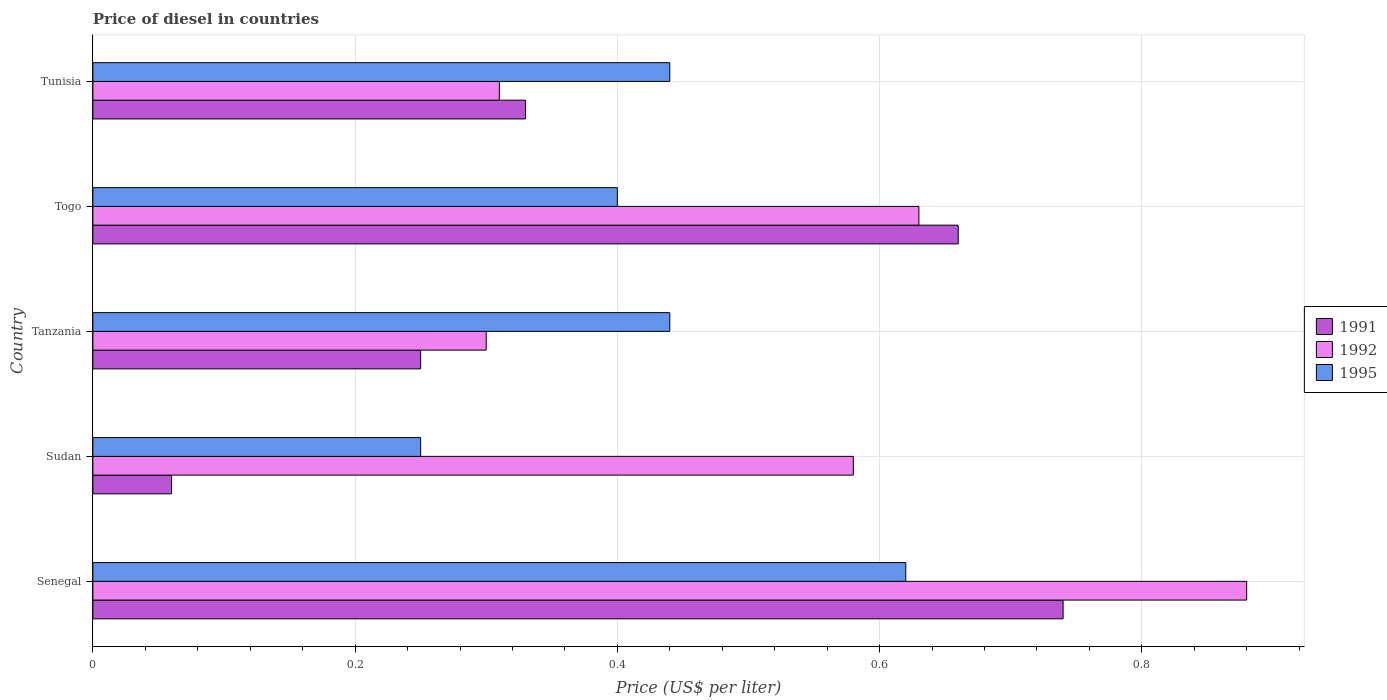How many groups of bars are there?
Give a very brief answer. 5. Are the number of bars per tick equal to the number of legend labels?
Your answer should be very brief. Yes. Are the number of bars on each tick of the Y-axis equal?
Offer a terse response. Yes. What is the label of the 2nd group of bars from the top?
Your response must be concise. Togo. What is the price of diesel in 1991 in Tanzania?
Offer a very short reply. 0.25. Across all countries, what is the maximum price of diesel in 1991?
Make the answer very short. 0.74. In which country was the price of diesel in 1995 maximum?
Make the answer very short. Senegal. In which country was the price of diesel in 1995 minimum?
Provide a short and direct response. Sudan. What is the total price of diesel in 1995 in the graph?
Your answer should be very brief. 2.15. What is the difference between the price of diesel in 1991 in Senegal and that in Togo?
Offer a very short reply. 0.08. What is the difference between the price of diesel in 1992 in Tunisia and the price of diesel in 1991 in Senegal?
Your answer should be compact. -0.43. What is the average price of diesel in 1992 per country?
Your answer should be very brief. 0.54. What is the difference between the price of diesel in 1995 and price of diesel in 1992 in Senegal?
Provide a succinct answer. -0.26. What is the ratio of the price of diesel in 1991 in Togo to that in Tunisia?
Give a very brief answer. 2. Is the price of diesel in 1991 in Togo less than that in Tunisia?
Give a very brief answer. No. Is the difference between the price of diesel in 1995 in Senegal and Togo greater than the difference between the price of diesel in 1992 in Senegal and Togo?
Ensure brevity in your answer.  No. What is the difference between the highest and the second highest price of diesel in 1991?
Your answer should be compact. 0.08. What is the difference between the highest and the lowest price of diesel in 1992?
Your answer should be compact. 0.58. Is the sum of the price of diesel in 1991 in Senegal and Togo greater than the maximum price of diesel in 1995 across all countries?
Offer a terse response. Yes. Is it the case that in every country, the sum of the price of diesel in 1991 and price of diesel in 1995 is greater than the price of diesel in 1992?
Provide a short and direct response. No. Are the values on the major ticks of X-axis written in scientific E-notation?
Your answer should be compact. No. Where does the legend appear in the graph?
Provide a short and direct response. Center right. How many legend labels are there?
Ensure brevity in your answer.  3. How are the legend labels stacked?
Your response must be concise. Vertical. What is the title of the graph?
Keep it short and to the point. Price of diesel in countries. Does "2012" appear as one of the legend labels in the graph?
Keep it short and to the point. No. What is the label or title of the X-axis?
Your answer should be very brief. Price (US$ per liter). What is the label or title of the Y-axis?
Give a very brief answer. Country. What is the Price (US$ per liter) of 1991 in Senegal?
Offer a terse response. 0.74. What is the Price (US$ per liter) in 1995 in Senegal?
Offer a very short reply. 0.62. What is the Price (US$ per liter) in 1992 in Sudan?
Your answer should be compact. 0.58. What is the Price (US$ per liter) in 1995 in Tanzania?
Provide a short and direct response. 0.44. What is the Price (US$ per liter) in 1991 in Togo?
Offer a terse response. 0.66. What is the Price (US$ per liter) of 1992 in Togo?
Offer a very short reply. 0.63. What is the Price (US$ per liter) in 1991 in Tunisia?
Offer a very short reply. 0.33. What is the Price (US$ per liter) in 1992 in Tunisia?
Offer a terse response. 0.31. What is the Price (US$ per liter) in 1995 in Tunisia?
Provide a succinct answer. 0.44. Across all countries, what is the maximum Price (US$ per liter) in 1991?
Provide a short and direct response. 0.74. Across all countries, what is the maximum Price (US$ per liter) of 1992?
Offer a terse response. 0.88. Across all countries, what is the maximum Price (US$ per liter) in 1995?
Make the answer very short. 0.62. Across all countries, what is the minimum Price (US$ per liter) in 1995?
Give a very brief answer. 0.25. What is the total Price (US$ per liter) in 1991 in the graph?
Your answer should be compact. 2.04. What is the total Price (US$ per liter) in 1995 in the graph?
Offer a terse response. 2.15. What is the difference between the Price (US$ per liter) in 1991 in Senegal and that in Sudan?
Provide a short and direct response. 0.68. What is the difference between the Price (US$ per liter) of 1995 in Senegal and that in Sudan?
Your answer should be very brief. 0.37. What is the difference between the Price (US$ per liter) in 1991 in Senegal and that in Tanzania?
Make the answer very short. 0.49. What is the difference between the Price (US$ per liter) in 1992 in Senegal and that in Tanzania?
Offer a very short reply. 0.58. What is the difference between the Price (US$ per liter) of 1995 in Senegal and that in Tanzania?
Make the answer very short. 0.18. What is the difference between the Price (US$ per liter) of 1991 in Senegal and that in Togo?
Your response must be concise. 0.08. What is the difference between the Price (US$ per liter) in 1995 in Senegal and that in Togo?
Provide a succinct answer. 0.22. What is the difference between the Price (US$ per liter) in 1991 in Senegal and that in Tunisia?
Make the answer very short. 0.41. What is the difference between the Price (US$ per liter) of 1992 in Senegal and that in Tunisia?
Provide a succinct answer. 0.57. What is the difference between the Price (US$ per liter) in 1995 in Senegal and that in Tunisia?
Provide a short and direct response. 0.18. What is the difference between the Price (US$ per liter) of 1991 in Sudan and that in Tanzania?
Give a very brief answer. -0.19. What is the difference between the Price (US$ per liter) of 1992 in Sudan and that in Tanzania?
Provide a short and direct response. 0.28. What is the difference between the Price (US$ per liter) in 1995 in Sudan and that in Tanzania?
Your answer should be compact. -0.19. What is the difference between the Price (US$ per liter) of 1991 in Sudan and that in Tunisia?
Your answer should be compact. -0.27. What is the difference between the Price (US$ per liter) of 1992 in Sudan and that in Tunisia?
Your answer should be very brief. 0.27. What is the difference between the Price (US$ per liter) of 1995 in Sudan and that in Tunisia?
Provide a succinct answer. -0.19. What is the difference between the Price (US$ per liter) of 1991 in Tanzania and that in Togo?
Your answer should be compact. -0.41. What is the difference between the Price (US$ per liter) in 1992 in Tanzania and that in Togo?
Your answer should be compact. -0.33. What is the difference between the Price (US$ per liter) of 1991 in Tanzania and that in Tunisia?
Your answer should be very brief. -0.08. What is the difference between the Price (US$ per liter) in 1992 in Tanzania and that in Tunisia?
Offer a terse response. -0.01. What is the difference between the Price (US$ per liter) in 1995 in Tanzania and that in Tunisia?
Ensure brevity in your answer.  0. What is the difference between the Price (US$ per liter) of 1991 in Togo and that in Tunisia?
Your answer should be very brief. 0.33. What is the difference between the Price (US$ per liter) in 1992 in Togo and that in Tunisia?
Give a very brief answer. 0.32. What is the difference between the Price (US$ per liter) in 1995 in Togo and that in Tunisia?
Provide a short and direct response. -0.04. What is the difference between the Price (US$ per liter) of 1991 in Senegal and the Price (US$ per liter) of 1992 in Sudan?
Keep it short and to the point. 0.16. What is the difference between the Price (US$ per liter) in 1991 in Senegal and the Price (US$ per liter) in 1995 in Sudan?
Your response must be concise. 0.49. What is the difference between the Price (US$ per liter) of 1992 in Senegal and the Price (US$ per liter) of 1995 in Sudan?
Make the answer very short. 0.63. What is the difference between the Price (US$ per liter) of 1991 in Senegal and the Price (US$ per liter) of 1992 in Tanzania?
Your response must be concise. 0.44. What is the difference between the Price (US$ per liter) in 1991 in Senegal and the Price (US$ per liter) in 1995 in Tanzania?
Offer a terse response. 0.3. What is the difference between the Price (US$ per liter) of 1992 in Senegal and the Price (US$ per liter) of 1995 in Tanzania?
Keep it short and to the point. 0.44. What is the difference between the Price (US$ per liter) of 1991 in Senegal and the Price (US$ per liter) of 1992 in Togo?
Provide a succinct answer. 0.11. What is the difference between the Price (US$ per liter) in 1991 in Senegal and the Price (US$ per liter) in 1995 in Togo?
Your answer should be compact. 0.34. What is the difference between the Price (US$ per liter) of 1992 in Senegal and the Price (US$ per liter) of 1995 in Togo?
Give a very brief answer. 0.48. What is the difference between the Price (US$ per liter) of 1991 in Senegal and the Price (US$ per liter) of 1992 in Tunisia?
Your answer should be compact. 0.43. What is the difference between the Price (US$ per liter) of 1991 in Senegal and the Price (US$ per liter) of 1995 in Tunisia?
Ensure brevity in your answer.  0.3. What is the difference between the Price (US$ per liter) of 1992 in Senegal and the Price (US$ per liter) of 1995 in Tunisia?
Provide a succinct answer. 0.44. What is the difference between the Price (US$ per liter) in 1991 in Sudan and the Price (US$ per liter) in 1992 in Tanzania?
Your answer should be very brief. -0.24. What is the difference between the Price (US$ per liter) of 1991 in Sudan and the Price (US$ per liter) of 1995 in Tanzania?
Give a very brief answer. -0.38. What is the difference between the Price (US$ per liter) in 1992 in Sudan and the Price (US$ per liter) in 1995 in Tanzania?
Provide a succinct answer. 0.14. What is the difference between the Price (US$ per liter) in 1991 in Sudan and the Price (US$ per liter) in 1992 in Togo?
Provide a short and direct response. -0.57. What is the difference between the Price (US$ per liter) in 1991 in Sudan and the Price (US$ per liter) in 1995 in Togo?
Offer a terse response. -0.34. What is the difference between the Price (US$ per liter) in 1992 in Sudan and the Price (US$ per liter) in 1995 in Togo?
Offer a very short reply. 0.18. What is the difference between the Price (US$ per liter) of 1991 in Sudan and the Price (US$ per liter) of 1992 in Tunisia?
Ensure brevity in your answer.  -0.25. What is the difference between the Price (US$ per liter) in 1991 in Sudan and the Price (US$ per liter) in 1995 in Tunisia?
Provide a succinct answer. -0.38. What is the difference between the Price (US$ per liter) in 1992 in Sudan and the Price (US$ per liter) in 1995 in Tunisia?
Keep it short and to the point. 0.14. What is the difference between the Price (US$ per liter) of 1991 in Tanzania and the Price (US$ per liter) of 1992 in Togo?
Make the answer very short. -0.38. What is the difference between the Price (US$ per liter) of 1991 in Tanzania and the Price (US$ per liter) of 1995 in Togo?
Provide a short and direct response. -0.15. What is the difference between the Price (US$ per liter) in 1992 in Tanzania and the Price (US$ per liter) in 1995 in Togo?
Offer a terse response. -0.1. What is the difference between the Price (US$ per liter) of 1991 in Tanzania and the Price (US$ per liter) of 1992 in Tunisia?
Make the answer very short. -0.06. What is the difference between the Price (US$ per liter) of 1991 in Tanzania and the Price (US$ per liter) of 1995 in Tunisia?
Give a very brief answer. -0.19. What is the difference between the Price (US$ per liter) of 1992 in Tanzania and the Price (US$ per liter) of 1995 in Tunisia?
Your answer should be compact. -0.14. What is the difference between the Price (US$ per liter) of 1991 in Togo and the Price (US$ per liter) of 1992 in Tunisia?
Ensure brevity in your answer.  0.35. What is the difference between the Price (US$ per liter) in 1991 in Togo and the Price (US$ per liter) in 1995 in Tunisia?
Provide a short and direct response. 0.22. What is the difference between the Price (US$ per liter) of 1992 in Togo and the Price (US$ per liter) of 1995 in Tunisia?
Make the answer very short. 0.19. What is the average Price (US$ per liter) in 1991 per country?
Offer a very short reply. 0.41. What is the average Price (US$ per liter) of 1992 per country?
Give a very brief answer. 0.54. What is the average Price (US$ per liter) of 1995 per country?
Provide a short and direct response. 0.43. What is the difference between the Price (US$ per liter) of 1991 and Price (US$ per liter) of 1992 in Senegal?
Provide a succinct answer. -0.14. What is the difference between the Price (US$ per liter) of 1991 and Price (US$ per liter) of 1995 in Senegal?
Your answer should be compact. 0.12. What is the difference between the Price (US$ per liter) in 1992 and Price (US$ per liter) in 1995 in Senegal?
Offer a terse response. 0.26. What is the difference between the Price (US$ per liter) of 1991 and Price (US$ per liter) of 1992 in Sudan?
Give a very brief answer. -0.52. What is the difference between the Price (US$ per liter) in 1991 and Price (US$ per liter) in 1995 in Sudan?
Give a very brief answer. -0.19. What is the difference between the Price (US$ per liter) in 1992 and Price (US$ per liter) in 1995 in Sudan?
Ensure brevity in your answer.  0.33. What is the difference between the Price (US$ per liter) of 1991 and Price (US$ per liter) of 1995 in Tanzania?
Your response must be concise. -0.19. What is the difference between the Price (US$ per liter) in 1992 and Price (US$ per liter) in 1995 in Tanzania?
Offer a terse response. -0.14. What is the difference between the Price (US$ per liter) in 1991 and Price (US$ per liter) in 1992 in Togo?
Offer a very short reply. 0.03. What is the difference between the Price (US$ per liter) of 1991 and Price (US$ per liter) of 1995 in Togo?
Offer a very short reply. 0.26. What is the difference between the Price (US$ per liter) in 1992 and Price (US$ per liter) in 1995 in Togo?
Give a very brief answer. 0.23. What is the difference between the Price (US$ per liter) in 1991 and Price (US$ per liter) in 1995 in Tunisia?
Keep it short and to the point. -0.11. What is the difference between the Price (US$ per liter) in 1992 and Price (US$ per liter) in 1995 in Tunisia?
Keep it short and to the point. -0.13. What is the ratio of the Price (US$ per liter) of 1991 in Senegal to that in Sudan?
Ensure brevity in your answer.  12.33. What is the ratio of the Price (US$ per liter) in 1992 in Senegal to that in Sudan?
Provide a short and direct response. 1.52. What is the ratio of the Price (US$ per liter) in 1995 in Senegal to that in Sudan?
Your answer should be compact. 2.48. What is the ratio of the Price (US$ per liter) of 1991 in Senegal to that in Tanzania?
Make the answer very short. 2.96. What is the ratio of the Price (US$ per liter) in 1992 in Senegal to that in Tanzania?
Make the answer very short. 2.93. What is the ratio of the Price (US$ per liter) in 1995 in Senegal to that in Tanzania?
Give a very brief answer. 1.41. What is the ratio of the Price (US$ per liter) in 1991 in Senegal to that in Togo?
Keep it short and to the point. 1.12. What is the ratio of the Price (US$ per liter) of 1992 in Senegal to that in Togo?
Provide a short and direct response. 1.4. What is the ratio of the Price (US$ per liter) in 1995 in Senegal to that in Togo?
Offer a very short reply. 1.55. What is the ratio of the Price (US$ per liter) in 1991 in Senegal to that in Tunisia?
Your answer should be compact. 2.24. What is the ratio of the Price (US$ per liter) in 1992 in Senegal to that in Tunisia?
Make the answer very short. 2.84. What is the ratio of the Price (US$ per liter) in 1995 in Senegal to that in Tunisia?
Your response must be concise. 1.41. What is the ratio of the Price (US$ per liter) of 1991 in Sudan to that in Tanzania?
Offer a terse response. 0.24. What is the ratio of the Price (US$ per liter) of 1992 in Sudan to that in Tanzania?
Make the answer very short. 1.93. What is the ratio of the Price (US$ per liter) of 1995 in Sudan to that in Tanzania?
Make the answer very short. 0.57. What is the ratio of the Price (US$ per liter) of 1991 in Sudan to that in Togo?
Make the answer very short. 0.09. What is the ratio of the Price (US$ per liter) of 1992 in Sudan to that in Togo?
Your answer should be very brief. 0.92. What is the ratio of the Price (US$ per liter) in 1991 in Sudan to that in Tunisia?
Offer a terse response. 0.18. What is the ratio of the Price (US$ per liter) of 1992 in Sudan to that in Tunisia?
Provide a succinct answer. 1.87. What is the ratio of the Price (US$ per liter) in 1995 in Sudan to that in Tunisia?
Provide a short and direct response. 0.57. What is the ratio of the Price (US$ per liter) of 1991 in Tanzania to that in Togo?
Your response must be concise. 0.38. What is the ratio of the Price (US$ per liter) of 1992 in Tanzania to that in Togo?
Offer a terse response. 0.48. What is the ratio of the Price (US$ per liter) of 1991 in Tanzania to that in Tunisia?
Ensure brevity in your answer.  0.76. What is the ratio of the Price (US$ per liter) in 1992 in Togo to that in Tunisia?
Offer a very short reply. 2.03. What is the difference between the highest and the second highest Price (US$ per liter) in 1991?
Offer a very short reply. 0.08. What is the difference between the highest and the second highest Price (US$ per liter) of 1992?
Keep it short and to the point. 0.25. What is the difference between the highest and the second highest Price (US$ per liter) of 1995?
Provide a short and direct response. 0.18. What is the difference between the highest and the lowest Price (US$ per liter) of 1991?
Your answer should be very brief. 0.68. What is the difference between the highest and the lowest Price (US$ per liter) of 1992?
Offer a terse response. 0.58. What is the difference between the highest and the lowest Price (US$ per liter) in 1995?
Give a very brief answer. 0.37. 